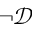Convert formula to latex. <formula><loc_0><loc_0><loc_500><loc_500>\neg \mathcal { D }</formula> 